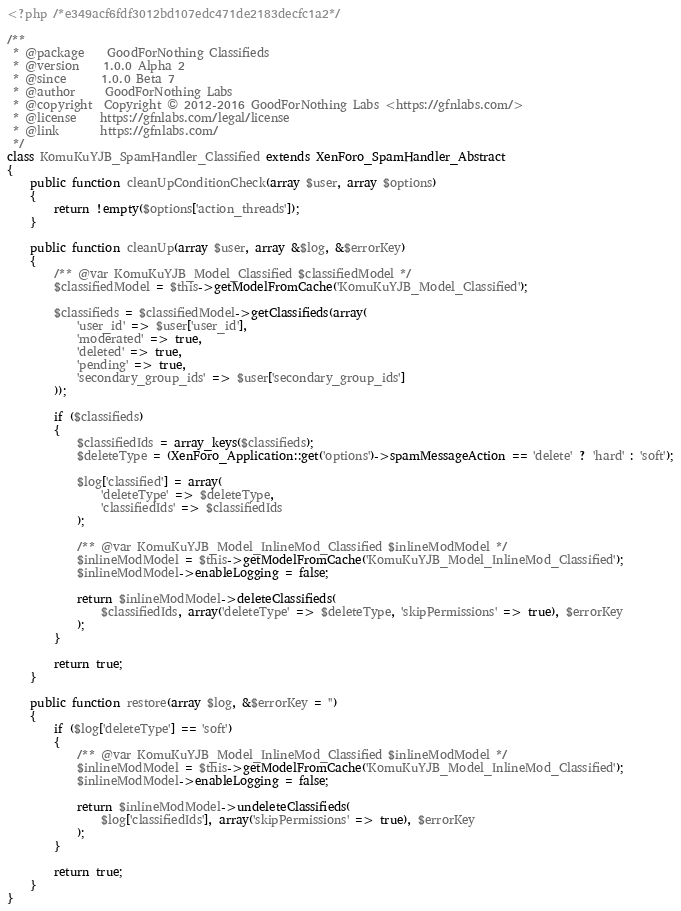<code> <loc_0><loc_0><loc_500><loc_500><_PHP_><?php /*e349acf6fdf3012bd107edc471de2183decfc1a2*/

/**
 * @package    GoodForNothing Classifieds
 * @version    1.0.0 Alpha 2
 * @since      1.0.0 Beta 7
 * @author     GoodForNothing Labs
 * @copyright  Copyright © 2012-2016 GoodForNothing Labs <https://gfnlabs.com/>
 * @license    https://gfnlabs.com/legal/license
 * @link       https://gfnlabs.com/
 */
class KomuKuYJB_SpamHandler_Classified extends XenForo_SpamHandler_Abstract
{
    public function cleanUpConditionCheck(array $user, array $options)
    {
        return !empty($options['action_threads']);
    }

    public function cleanUp(array $user, array &$log, &$errorKey)
    {
        /** @var KomuKuYJB_Model_Classified $classifiedModel */
        $classifiedModel = $this->getModelFromCache('KomuKuYJB_Model_Classified');

        $classifieds = $classifiedModel->getClassifieds(array(
            'user_id' => $user['user_id'],
            'moderated' => true,
            'deleted' => true,
            'pending' => true,
            'secondary_group_ids' => $user['secondary_group_ids']
        ));

        if ($classifieds)
        {
            $classifiedIds = array_keys($classifieds);
            $deleteType = (XenForo_Application::get('options')->spamMessageAction == 'delete' ? 'hard' : 'soft');

            $log['classified'] = array(
                'deleteType' => $deleteType,
                'classifiedIds' => $classifiedIds
            );

            /** @var KomuKuYJB_Model_InlineMod_Classified $inlineModModel */
            $inlineModModel = $this->getModelFromCache('KomuKuYJB_Model_InlineMod_Classified');
            $inlineModModel->enableLogging = false;

            return $inlineModModel->deleteClassifieds(
                $classifiedIds, array('deleteType' => $deleteType, 'skipPermissions' => true), $errorKey
            );
        }

        return true;
    }

    public function restore(array $log, &$errorKey = '')
    {
        if ($log['deleteType'] == 'soft')
        {
            /** @var KomuKuYJB_Model_InlineMod_Classified $inlineModModel */
            $inlineModModel = $this->getModelFromCache('KomuKuYJB_Model_InlineMod_Classified');
            $inlineModModel->enableLogging = false;

            return $inlineModModel->undeleteClassifieds(
                $log['classifiedIds'], array('skipPermissions' => true), $errorKey
            );
        }

        return true;
    }
}</code> 